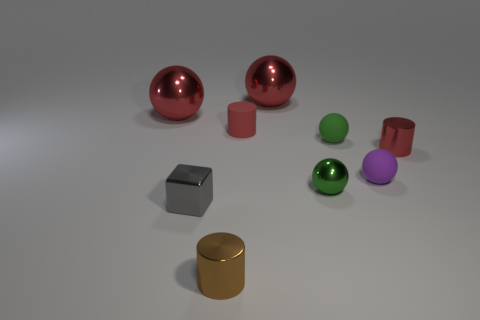Subtract all purple balls. How many balls are left? 4 Subtract all brown balls. Subtract all gray cubes. How many balls are left? 5 Subtract all balls. How many objects are left? 4 Subtract all large things. Subtract all small blocks. How many objects are left? 6 Add 3 tiny green rubber spheres. How many tiny green rubber spheres are left? 4 Add 9 brown metal things. How many brown metal things exist? 10 Subtract 0 yellow blocks. How many objects are left? 9 